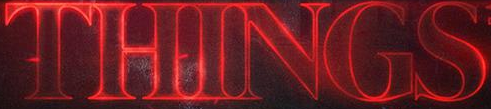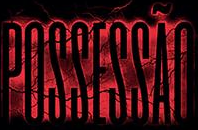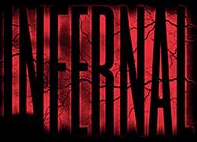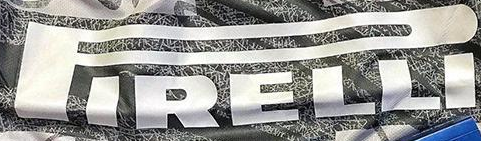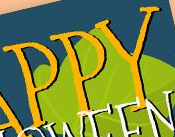Read the text content from these images in order, separated by a semicolon. THINGS; POSSESSÃO; INFERNAL; PIRELLI; PPY 